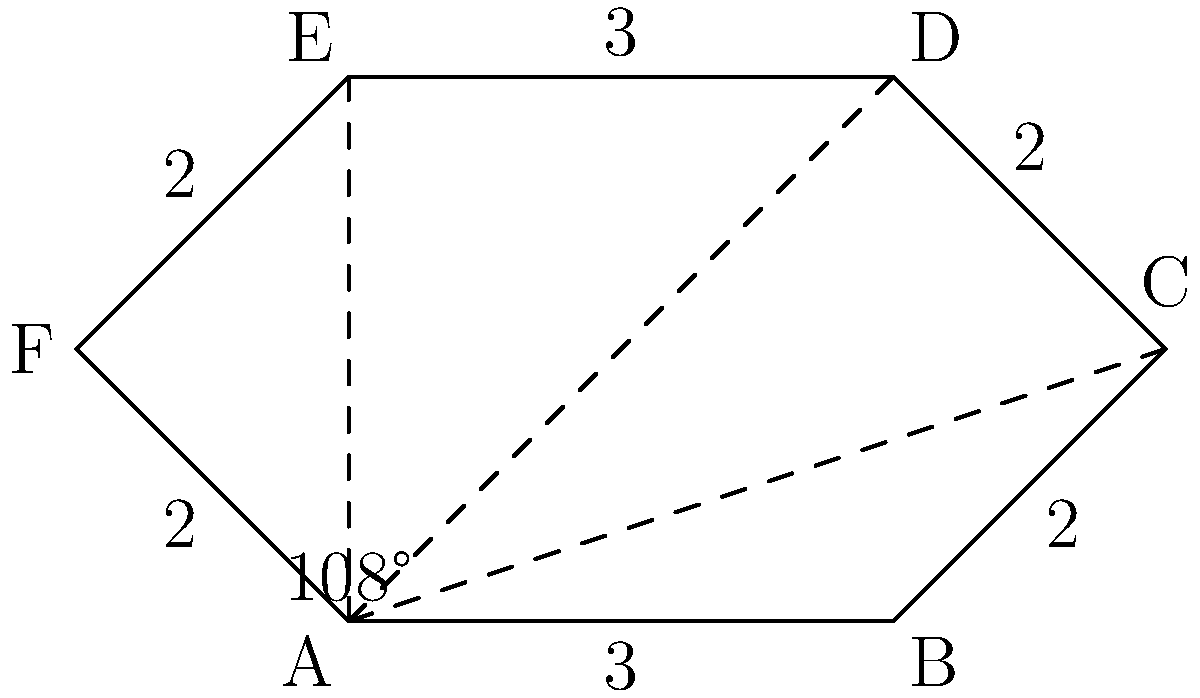In our town, a star-shaped monument has been erected to commemorate the victims of World War II. The monument is in the shape of a regular hexagram (six-pointed star) with side lengths alternating between 2 and 3 meters. If the interior angle at each point of the star is 108°, what is the total area of the monument in square meters? Let's approach this step-by-step:

1) The hexagram can be divided into six equilateral triangles and a regular hexagon in the center.

2) First, let's calculate the area of one equilateral triangle:
   - The side length is 3 meters
   - Area of an equilateral triangle = $\frac{\sqrt{3}}{4}a^2$, where $a$ is the side length
   - Area = $\frac{\sqrt{3}}{4} \cdot 3^2 = \frac{9\sqrt{3}}{4}$ square meters

3) Now, let's find the area of the central hexagon:
   - The hexagon is made up of six equilateral triangles
   - These triangles have a side length of 2 meters
   - Area of one small triangle = $\frac{\sqrt{3}}{4} \cdot 2^2 = \sqrt{3}$ square meters
   - Area of hexagon = $6 \cdot \sqrt{3} = 6\sqrt{3}$ square meters

4) The total area is the sum of the six large triangles and the central hexagon:
   Total Area = $6 \cdot \frac{9\sqrt{3}}{4} + 6\sqrt{3}$
               = $\frac{54\sqrt{3}}{4} + 6\sqrt{3}$
               = $\frac{54\sqrt{3}}{4} + \frac{24\sqrt{3}}{4}$
               = $\frac{78\sqrt{3}}{4}$
               = $19.5\sqrt{3}$ square meters

5) Rounding to two decimal places: 33.78 square meters
Answer: 33.78 m² 